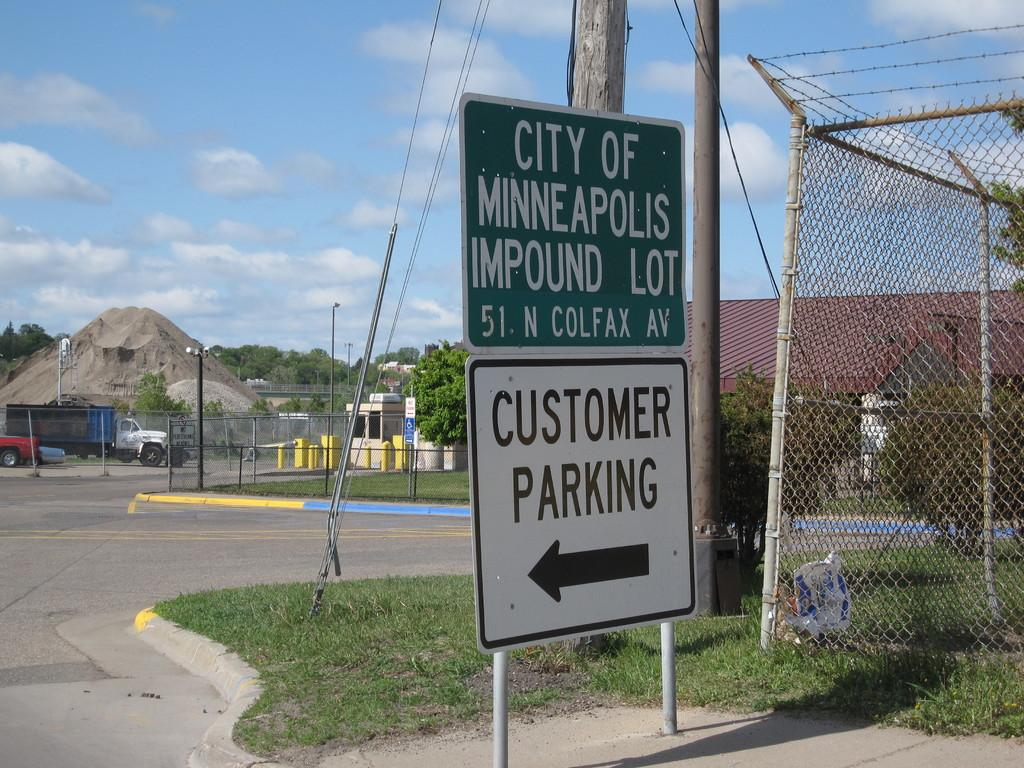What type of structures can be seen in the image? There are houses in the image. What vehicles are parked in the image? There are cars parked in the image. What safety measure is present in the image? There is a caution board in the image. What type of barrier is visible in the image? There is a metal fence in the image. What type of vegetation is present on the ground in the image? There is grass on the ground in the image. What vertical structures are present in the image? There are poles in the image. What is the condition of the sky in the image? The sky is blue and cloudy in the image. What science class is being taught in the image? There is no indication of a science class or any educational activity in the image. Can you see any dinosaurs in the image? There are no dinosaurs present in the image. 